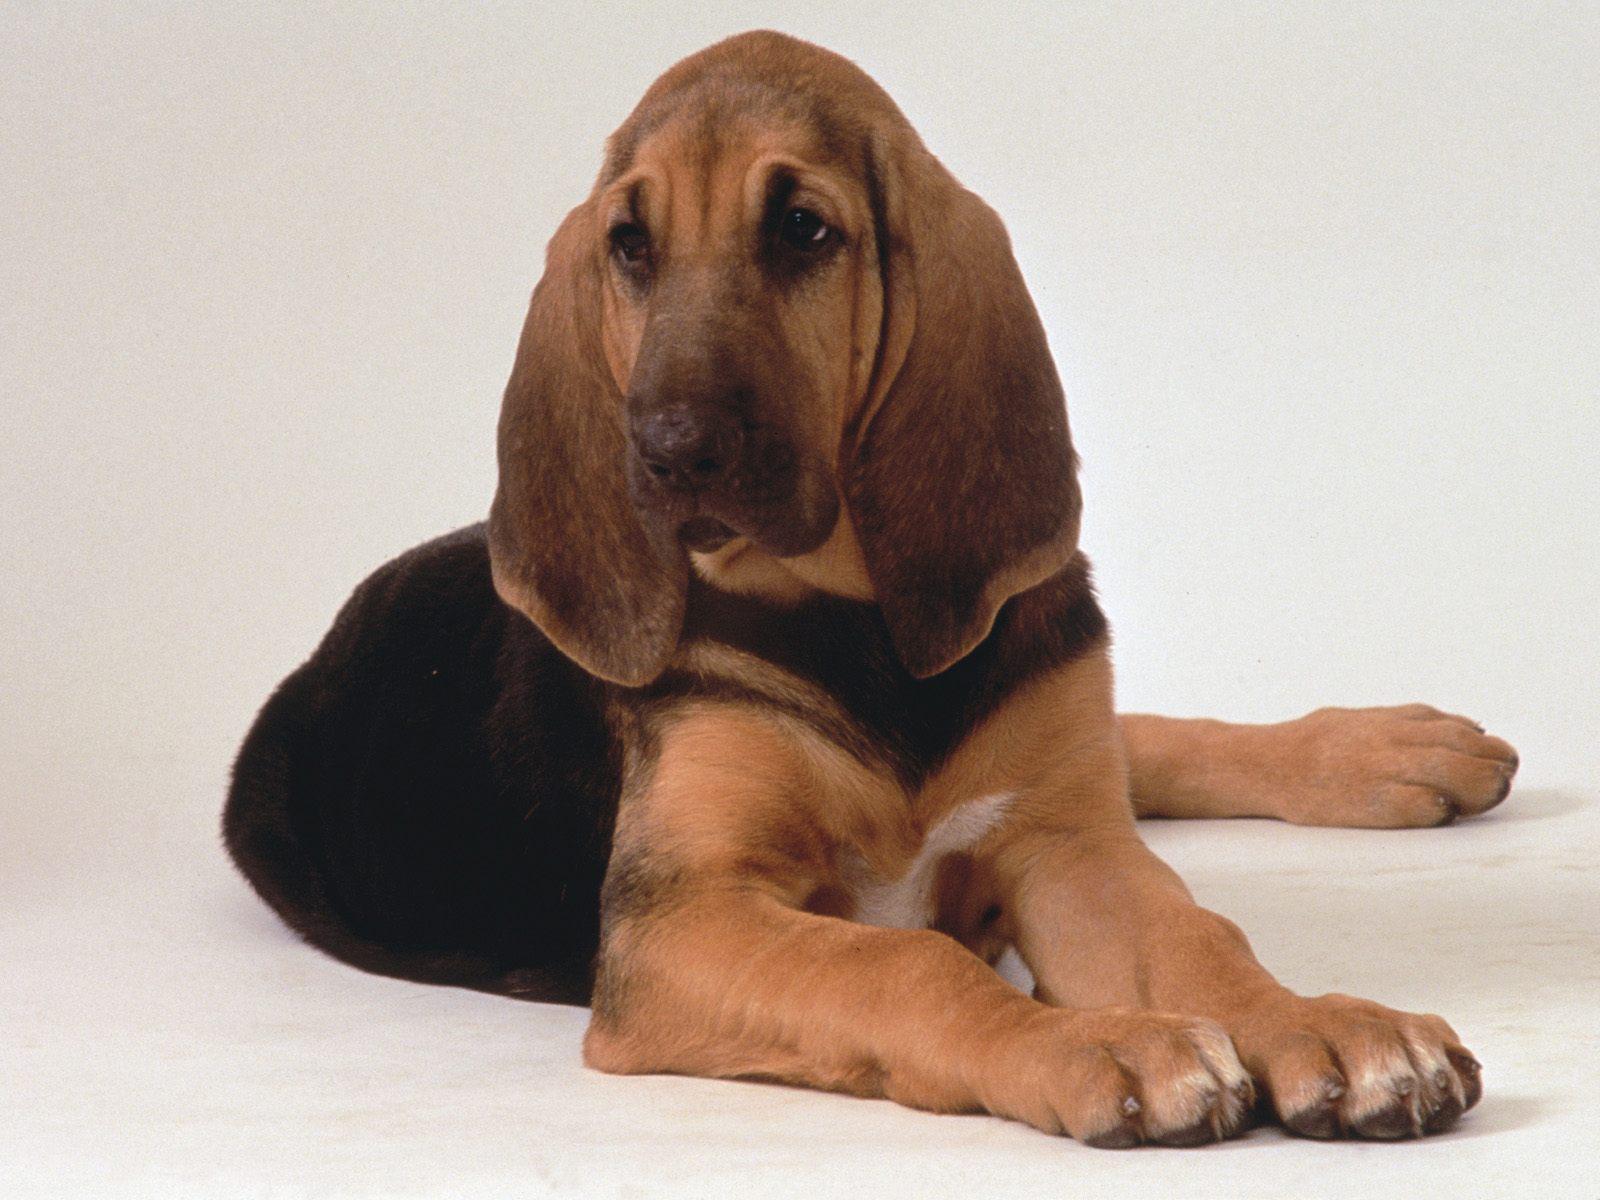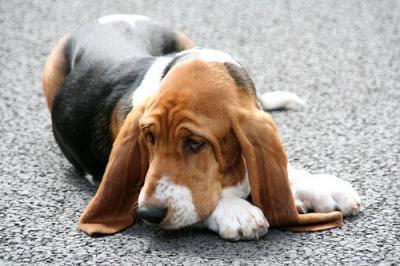The first image is the image on the left, the second image is the image on the right. For the images shown, is this caption "The dog in the image on the right is outside." true? Answer yes or no. Yes. 